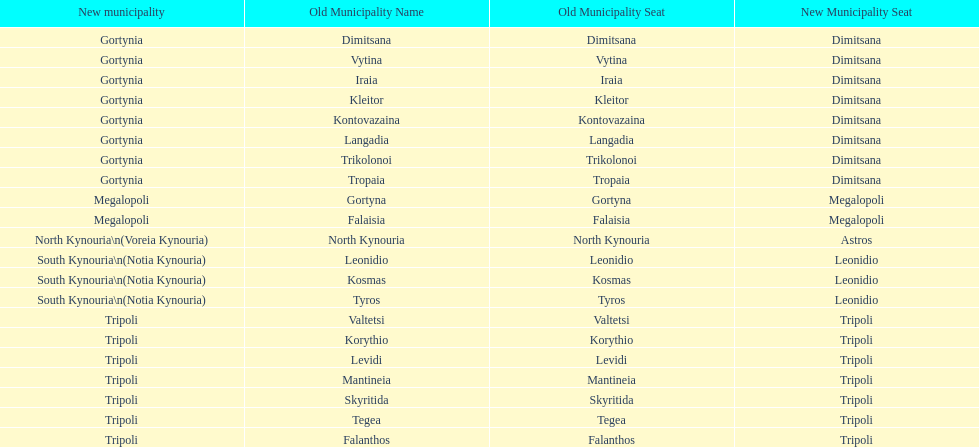When arcadia was reformed in 2011, how many municipalities were created? 5. 